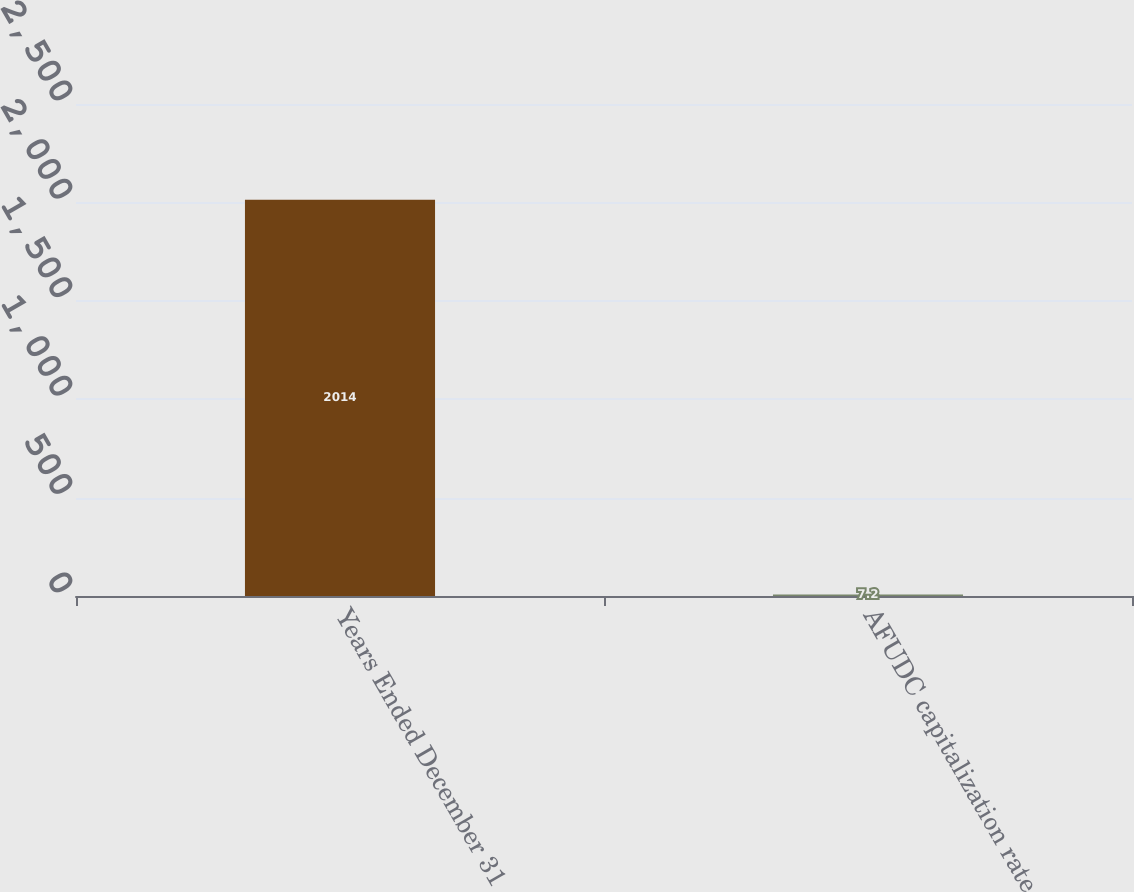Convert chart. <chart><loc_0><loc_0><loc_500><loc_500><bar_chart><fcel>Years Ended December 31<fcel>AFUDC capitalization rate<nl><fcel>2014<fcel>7.2<nl></chart> 